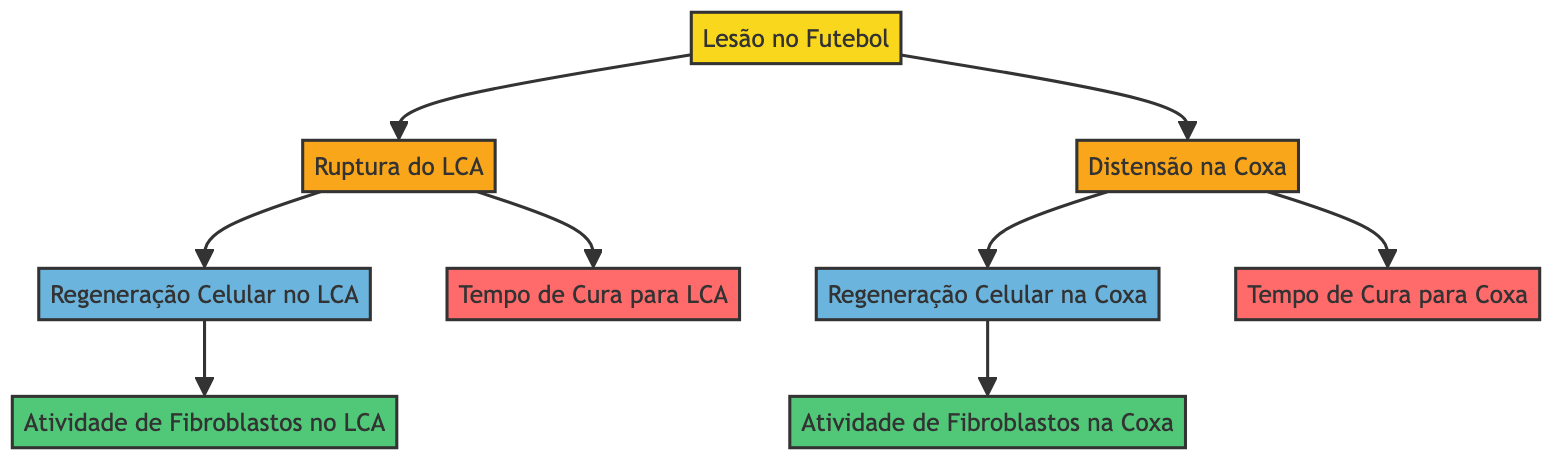What are two common types of football injuries shown? The diagram explicitly lists two injuries under the category of football injury: ACL tears and hamstring strains. These are the subcategories branching from the main node.
Answer: ACL tears and hamstring strains How many mechanisms of cellular regeneration are displayed in the diagram? The diagram contains two mechanisms of cellular regeneration, one for ACL tears and one for hamstring strains. These mechanisms are indicated as separate nodes that link from the respective injuries.
Answer: 2 What cell process is associated with ACL tears? The diagram connects the ACL tear to the cell process node labeled "Atividade de Fibroblastos no LCA," which indicates the fibroblast activity related to cellular regeneration in ACL injuries.
Answer: Atividade de Fibroblastos no LCA What is the healing time associated with hamstring strains? The diagram shows that the healing time for hamstring strains is represented by the node labeled "Tempo de Cura para Coxa." This is linked directly from the hamstring strain node.
Answer: Tempo de Cura para Coxa Which injury has a direct link to cellular regeneration? The diagram illustrates that both injuries (ACL tear and hamstring strain) connect to their respective cellular regeneration mechanisms, indicating that both injuries have a direct link to cellular regeneration processes. However, we can specify one of them, for example, the ACL tear linked to its cellular regeneration.
Answer: Ruptura do LCA What is the relationship between fibroblast activity and ACL tears? Fibroblast activity is identified as a cell process that directly stems from the ACL tear in the diagram. This means that fibroblast activity occurs as a response mechanism in the context of ACL injury recovery.
Answer: Atividade de Fibroblastos no LCA Is the healing time for ACL tears displayed in the diagram? Yes, the diagram clearly shows a node labeled "Tempo de Cura para LCA," which indicates the healing time related to ACL tears. This node is a direct result of injury classification in the diagram.
Answer: Tempo de Cura para LCA What color is used for the mechanism of cellular regeneration nodes? The diagram uses a distinctive blue color (denoted by the fill color #6bb4dd) for the mechanism nodes associated with cellular regeneration for both ACL tears and hamstring strains.
Answer: Blue 